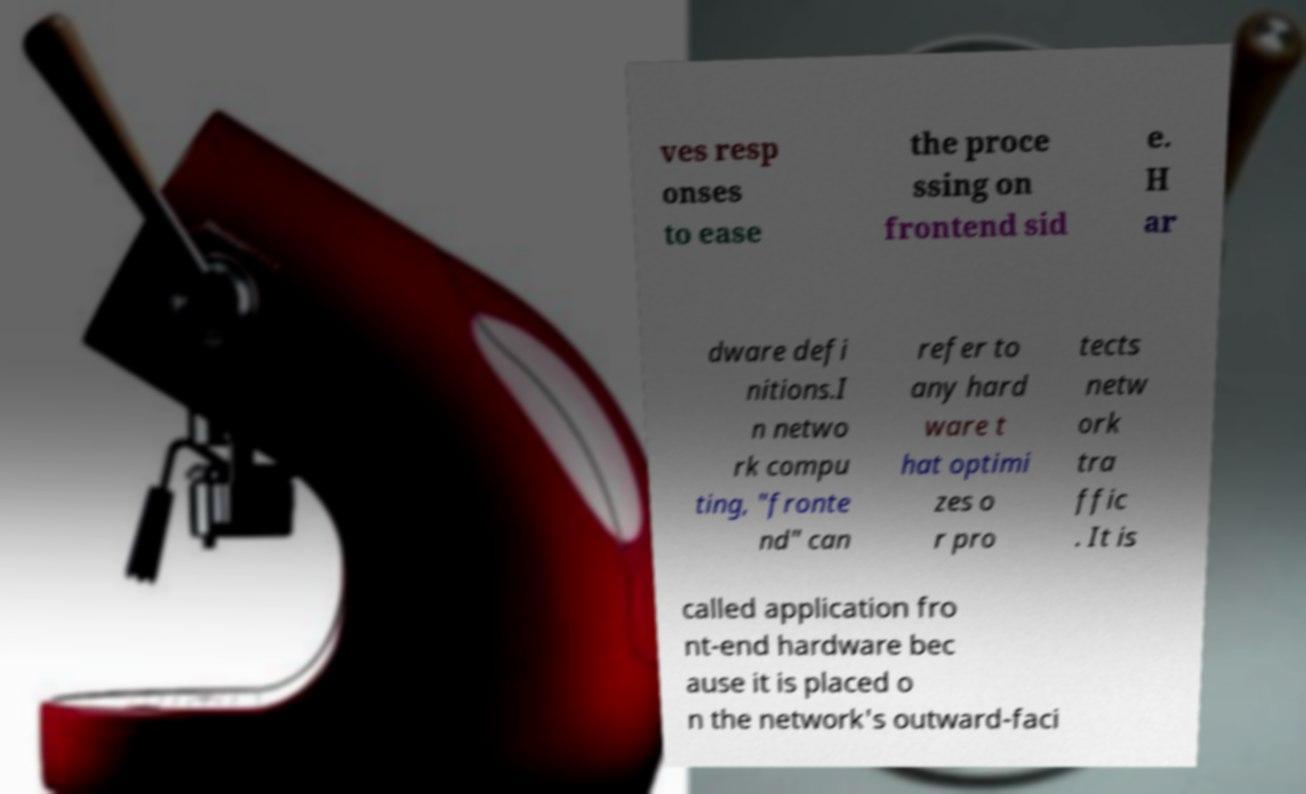Please read and relay the text visible in this image. What does it say? ves resp onses to ease the proce ssing on frontend sid e. H ar dware defi nitions.I n netwo rk compu ting, "fronte nd" can refer to any hard ware t hat optimi zes o r pro tects netw ork tra ffic . It is called application fro nt-end hardware bec ause it is placed o n the network's outward-faci 